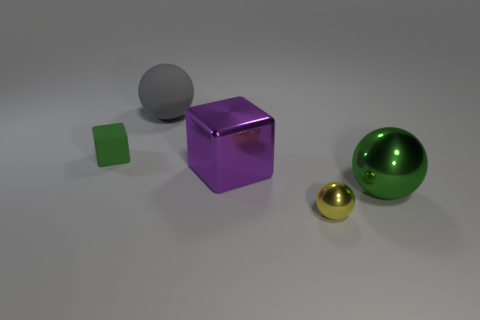Subtract all big green metal balls. How many balls are left? 2 Add 2 tiny purple shiny blocks. How many objects exist? 7 Subtract all green spheres. How many spheres are left? 2 Subtract 1 gray balls. How many objects are left? 4 Subtract all blocks. How many objects are left? 3 Subtract all blue blocks. Subtract all green spheres. How many blocks are left? 2 Subtract all gray matte balls. Subtract all tiny balls. How many objects are left? 3 Add 4 large spheres. How many large spheres are left? 6 Add 5 big matte balls. How many big matte balls exist? 6 